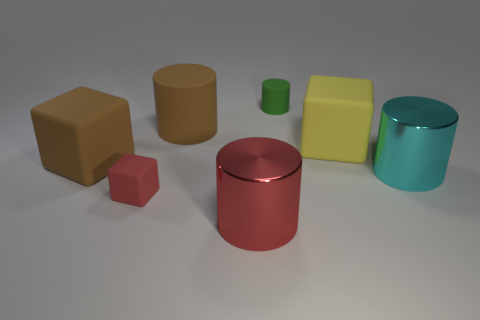What color is the big rubber cylinder?
Your answer should be compact. Brown. Is there a big brown block made of the same material as the brown cylinder?
Offer a terse response. Yes. There is a large metal cylinder behind the large object in front of the cyan metal cylinder; are there any tiny objects in front of it?
Offer a very short reply. Yes. Are there any big yellow blocks on the right side of the large cyan metal cylinder?
Your response must be concise. No. Is there a big shiny cylinder of the same color as the tiny rubber cylinder?
Provide a succinct answer. No. How many big objects are red shiny objects or green spheres?
Make the answer very short. 1. Do the large thing that is behind the large yellow block and the cyan cylinder have the same material?
Give a very brief answer. No. There is a tiny red thing that is in front of the large cylinder that is to the right of the cylinder that is in front of the small red block; what is its shape?
Give a very brief answer. Cube. How many blue things are either large matte cubes or tiny rubber cylinders?
Make the answer very short. 0. Is the number of big matte things that are behind the red matte object the same as the number of large cyan metal objects left of the tiny green rubber object?
Offer a very short reply. No. 